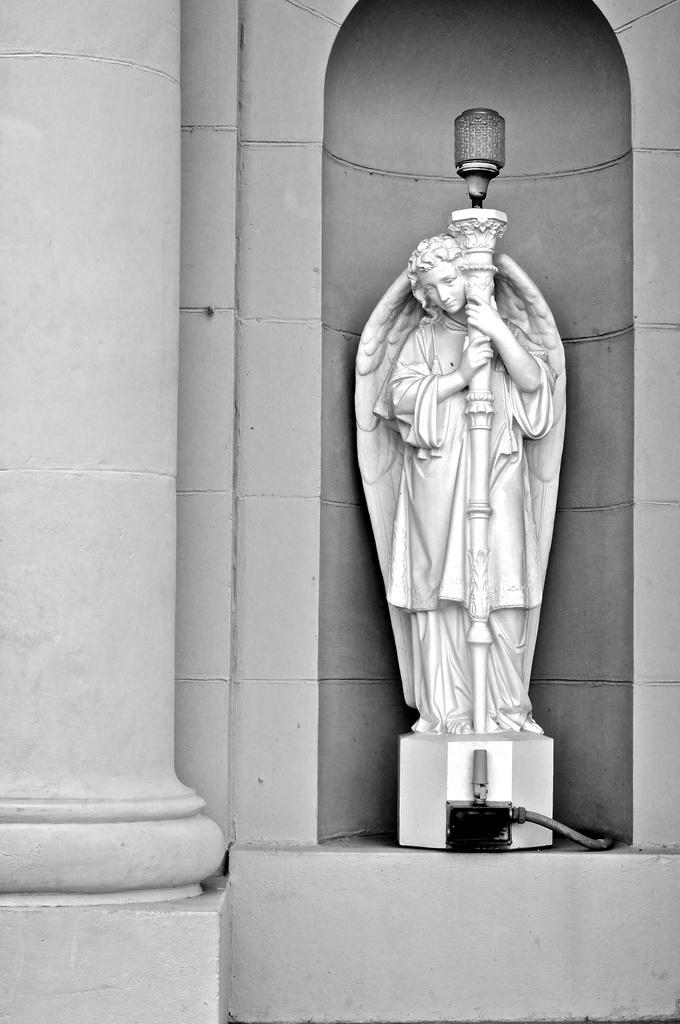What is the color scheme of the image? The image is black and white. What is the main subject of the image? There is a sculpture of a person with wings in the image. What is the person in the sculpture doing? The person is standing and holding a light pole. What can be seen on the left side of the image? There is a pillar on the left side of the image. How many sisters are depicted in the image? There are no sisters depicted in the image; it features a sculpture of a person with wings. What type of system is being used to power the town in the image? There is no town or system present in the image; it is a sculpture of a person with wings holding a light pole. 